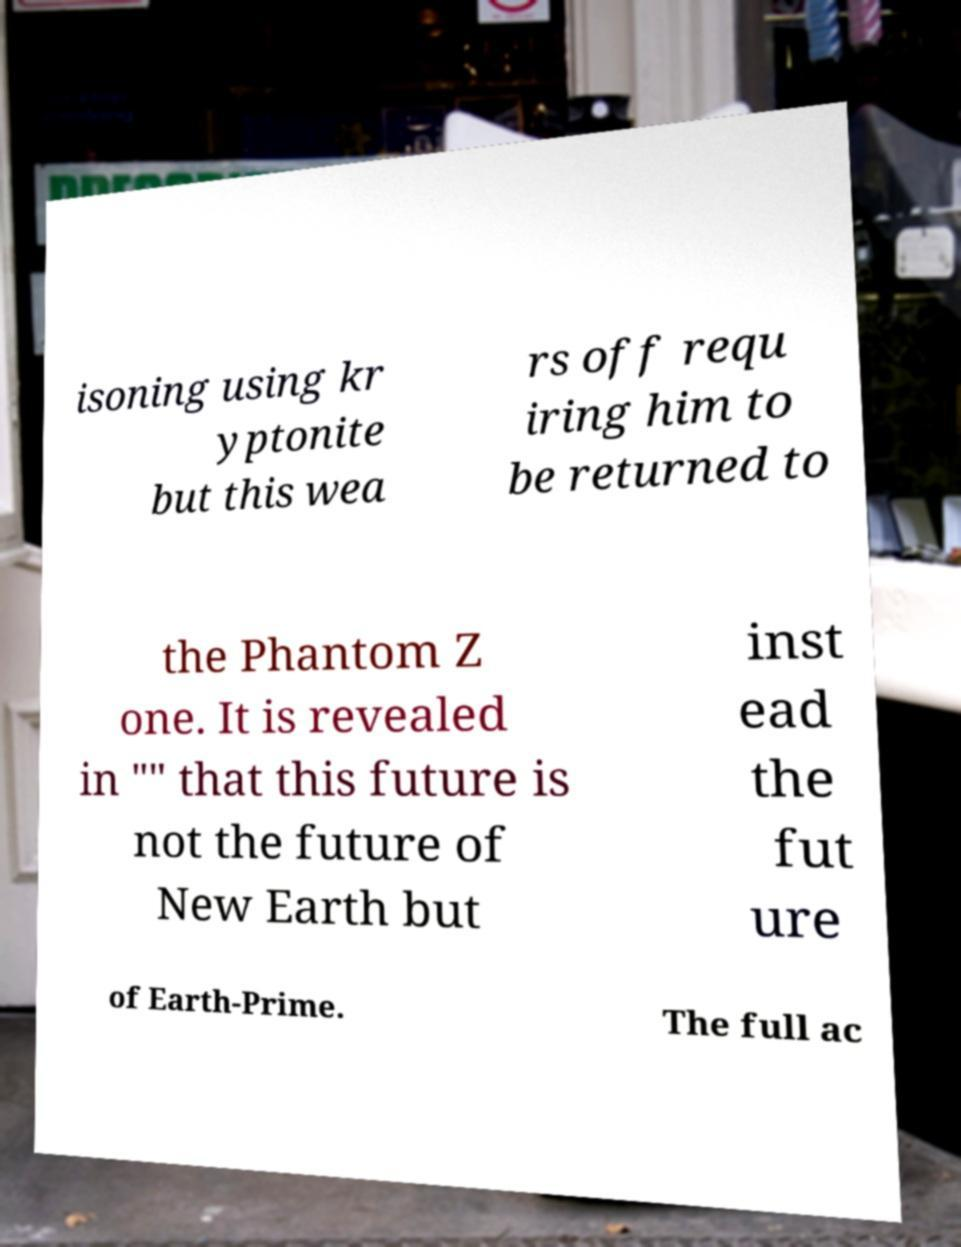Please read and relay the text visible in this image. What does it say? isoning using kr yptonite but this wea rs off requ iring him to be returned to the Phantom Z one. It is revealed in "" that this future is not the future of New Earth but inst ead the fut ure of Earth-Prime. The full ac 